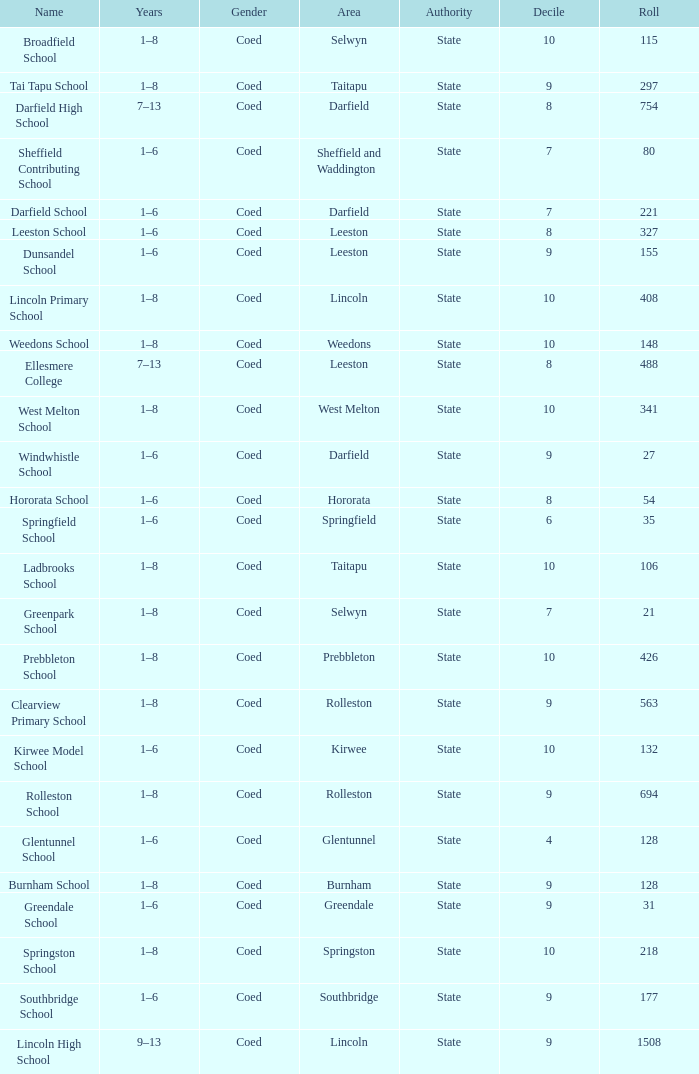Which name has a Roll larger than 297, and Years of 7–13? Darfield High School, Ellesmere College. 